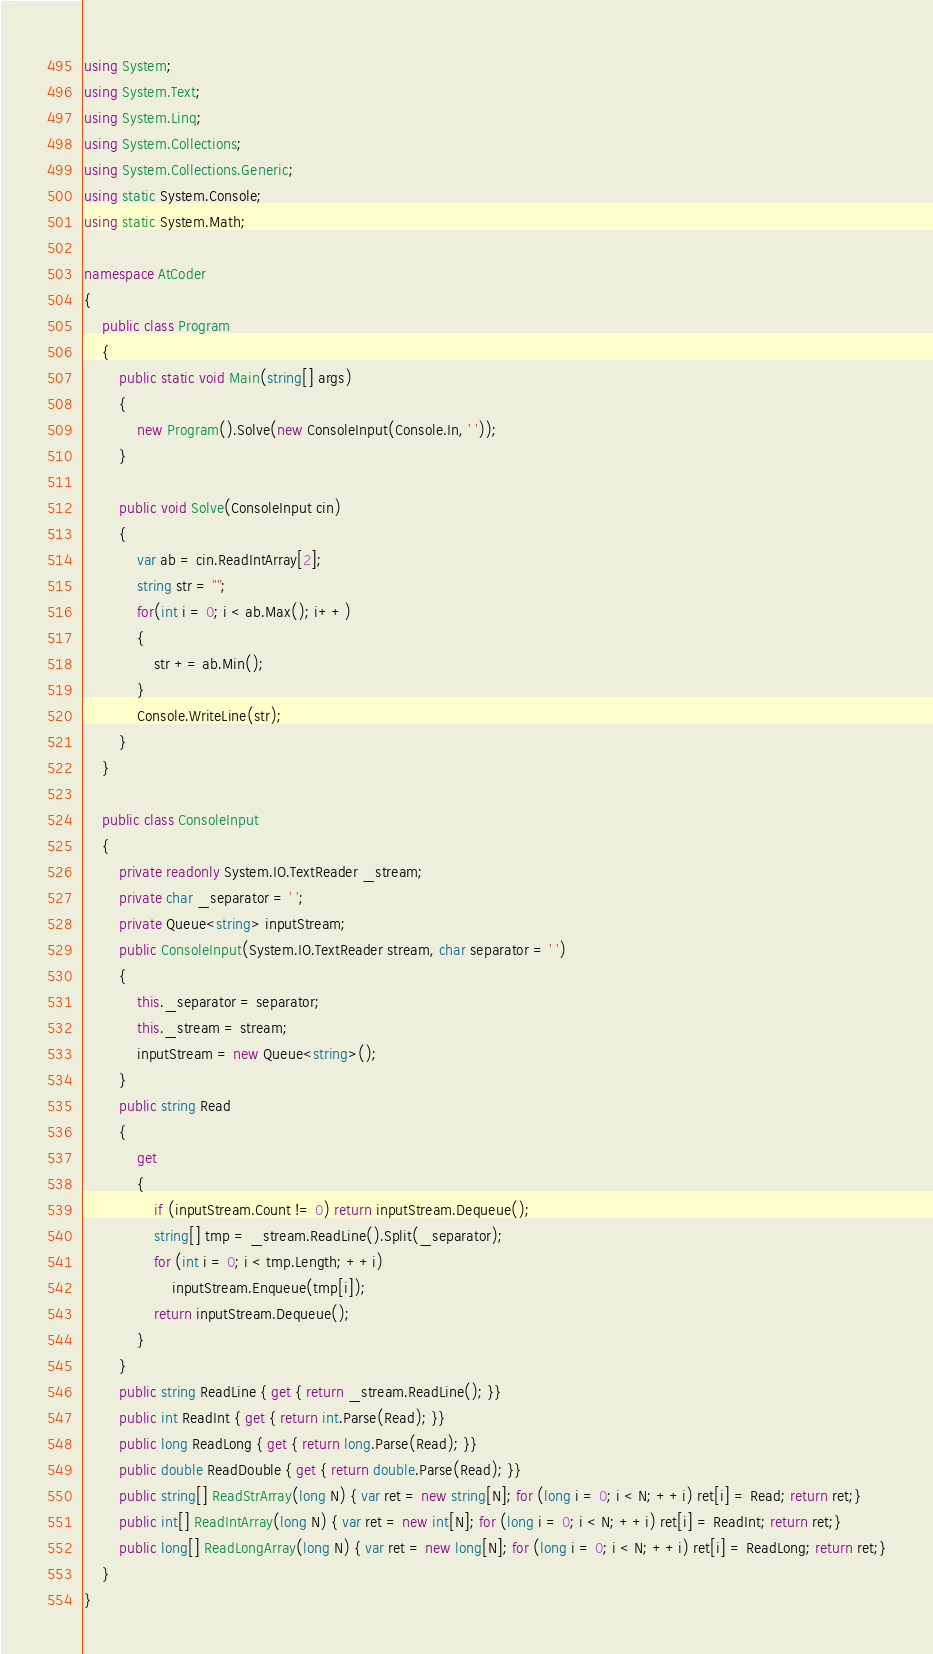Convert code to text. <code><loc_0><loc_0><loc_500><loc_500><_C#_>using System;
using System.Text;
using System.Linq;
using System.Collections;
using System.Collections.Generic;
using static System.Console;
using static System.Math;

namespace AtCoder
{
    public class Program
    {
        public static void Main(string[] args)
        {
            new Program().Solve(new ConsoleInput(Console.In, ' '));
        }

        public void Solve(ConsoleInput cin)
        {
            var ab = cin.ReadIntArray[2];
            string str = "";
            for(int i = 0; i < ab.Max(); i++)
            {
                str += ab.Min();
            }
            Console.WriteLine(str);
        }
    }

    public class ConsoleInput
    {
        private readonly System.IO.TextReader _stream;
        private char _separator = ' ';
        private Queue<string> inputStream;
        public ConsoleInput(System.IO.TextReader stream, char separator = ' ')
        {
            this._separator = separator;
            this._stream = stream;
            inputStream = new Queue<string>();
        }
        public string Read
        {
            get
            {
                if (inputStream.Count != 0) return inputStream.Dequeue();
                string[] tmp = _stream.ReadLine().Split(_separator);
                for (int i = 0; i < tmp.Length; ++i)
                    inputStream.Enqueue(tmp[i]);
                return inputStream.Dequeue();
            }
        }
        public string ReadLine { get { return _stream.ReadLine(); }}
        public int ReadInt { get { return int.Parse(Read); }}
        public long ReadLong { get { return long.Parse(Read); }}
        public double ReadDouble { get { return double.Parse(Read); }}
        public string[] ReadStrArray(long N) { var ret = new string[N]; for (long i = 0; i < N; ++i) ret[i] = Read; return ret;}
        public int[] ReadIntArray(long N) { var ret = new int[N]; for (long i = 0; i < N; ++i) ret[i] = ReadInt; return ret;}
        public long[] ReadLongArray(long N) { var ret = new long[N]; for (long i = 0; i < N; ++i) ret[i] = ReadLong; return ret;}
    }
}</code> 